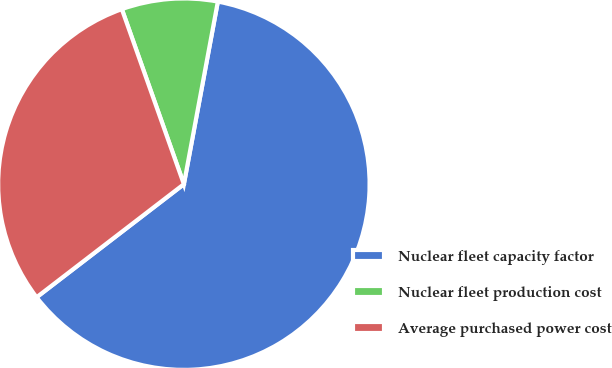Convert chart to OTSL. <chart><loc_0><loc_0><loc_500><loc_500><pie_chart><fcel>Nuclear fleet capacity factor<fcel>Nuclear fleet production cost<fcel>Average purchased power cost<nl><fcel>61.65%<fcel>8.35%<fcel>30.0%<nl></chart> 